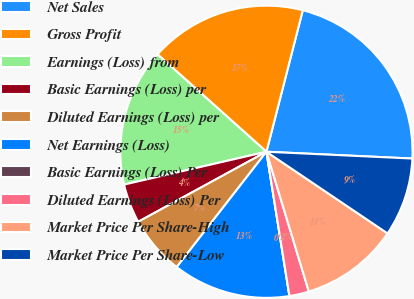Convert chart. <chart><loc_0><loc_0><loc_500><loc_500><pie_chart><fcel>Net Sales<fcel>Gross Profit<fcel>Earnings (Loss) from<fcel>Basic Earnings (Loss) per<fcel>Diluted Earnings (Loss) per<fcel>Net Earnings (Loss)<fcel>Basic Earnings (Loss) Per<fcel>Diluted Earnings (Loss) Per<fcel>Market Price Per Share-High<fcel>Market Price Per Share-Low<nl><fcel>21.74%<fcel>17.39%<fcel>15.22%<fcel>4.35%<fcel>6.52%<fcel>13.04%<fcel>0.0%<fcel>2.17%<fcel>10.87%<fcel>8.7%<nl></chart> 